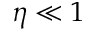Convert formula to latex. <formula><loc_0><loc_0><loc_500><loc_500>\eta \ll 1</formula> 